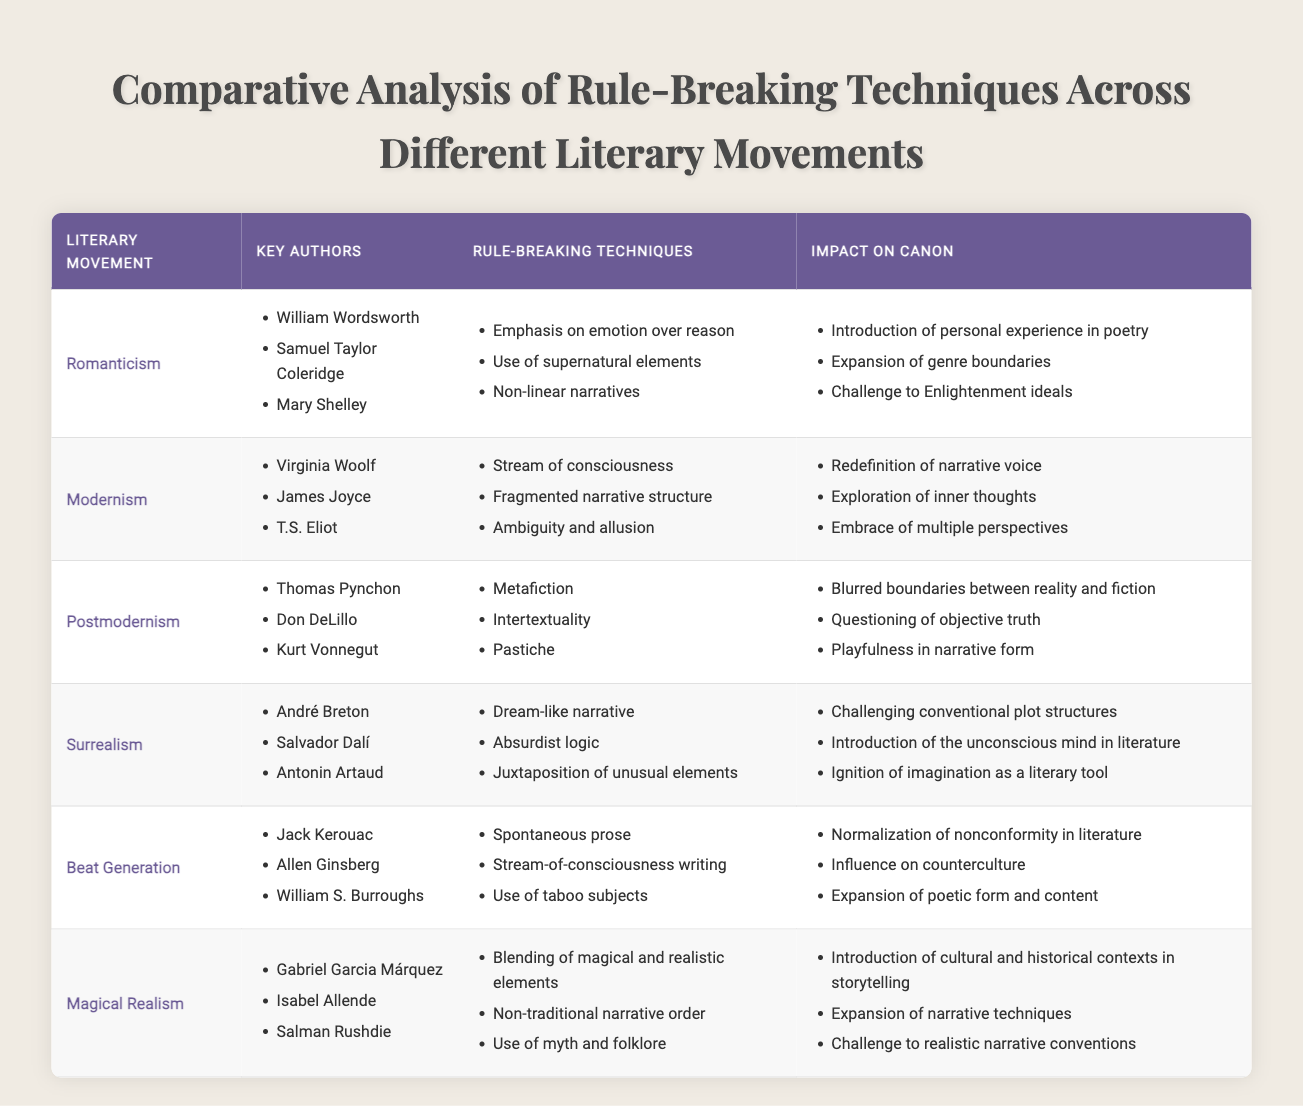What major rule-breaking technique distinguishes Modernism from Romanticism? Modernism employs stream of consciousness as a significant rule-breaking technique, while Romanticism emphasizes emotion over reason. By comparing the "Rule-Breaking Techniques" column for both movements, it's clear that stream of consciousness is not listed under Romanticism, indicating a key distinction.
Answer: Stream of consciousness Which literary movement introduces the concept of metafiction? According to the table, metafiction is listed as a rule-breaking technique specifically under the Postmodernism movement. Thus, it indicates that this concept was introduced in that literary period.
Answer: Postmodernism How many key authors are associated with the Beat Generation? The table indicates three key authors—Jack Kerouac, Allen Ginsberg, and William S. Burroughs—listed under the Beat Generation. Therefore, the total number of key authors is three.
Answer: Three Does Surrealism utilize absurdist logic in its narrative techniques? The table lists absurdist logic as one of the rule-breaking techniques used in Surrealism. This confirms that Surrealism does indeed make use of this particular narrative technique.
Answer: Yes Which literary movement has the most expansive impact on the canon, as evidenced by the number of implicated impacts listed? By examining the "Impact on Canon" column, each movement has three impacts listed except for Surrealism. Romanticism, Modernism, Postmodernism, and Beat Generation all show an equal number of impacts (three), while Surrealism does as well. Therefore, no single movement stands out with a greater number of impacts.
Answer: None (they are all equal) What is the implication of supernatural elements in the context of Romanticism? The table notes that one rule-breaking technique in Romanticism is the use of supernatural elements, which led to the introduction of personal experience in poetry as indicated in the "Impact on Canon" section. This implies that supernatural elements opened up new emotional and experiential dimensions in poetry.
Answer: Introduction of personal experience in poetry Identify which literary movements challenge conventional plot structures and how. Surrealism appears to challenge conventional plot structures through dream-like narratives and absurdist logic. If we look at the "Impact on Canon," Surrealism also challenges established narrative norms, which further supports this conclusion of rule-breaking.
Answer: Surrealism How does Magical Realism differ from the realism of the Enlightenment period? The table asserts that Magical Realism blends magical and realistic elements and introduces non-traditional narrative forms. This is a direct contrast to the realism of the Enlightenment, which typically avoided magical elements, thus representing a significant divergence in narrative approach.
Answer: Blending magical and realistic elements What potential impact did the Beat Generation literature have on society according to the table? The "Impact on Canon" for the Beat Generation mentions normalization of nonconformity, influencing counterculture significantly, as well as expanding poetic forms. This illustrates a considerable impact on societal values, notably in literature and culture.
Answer: Normalization of nonconformity in literature 